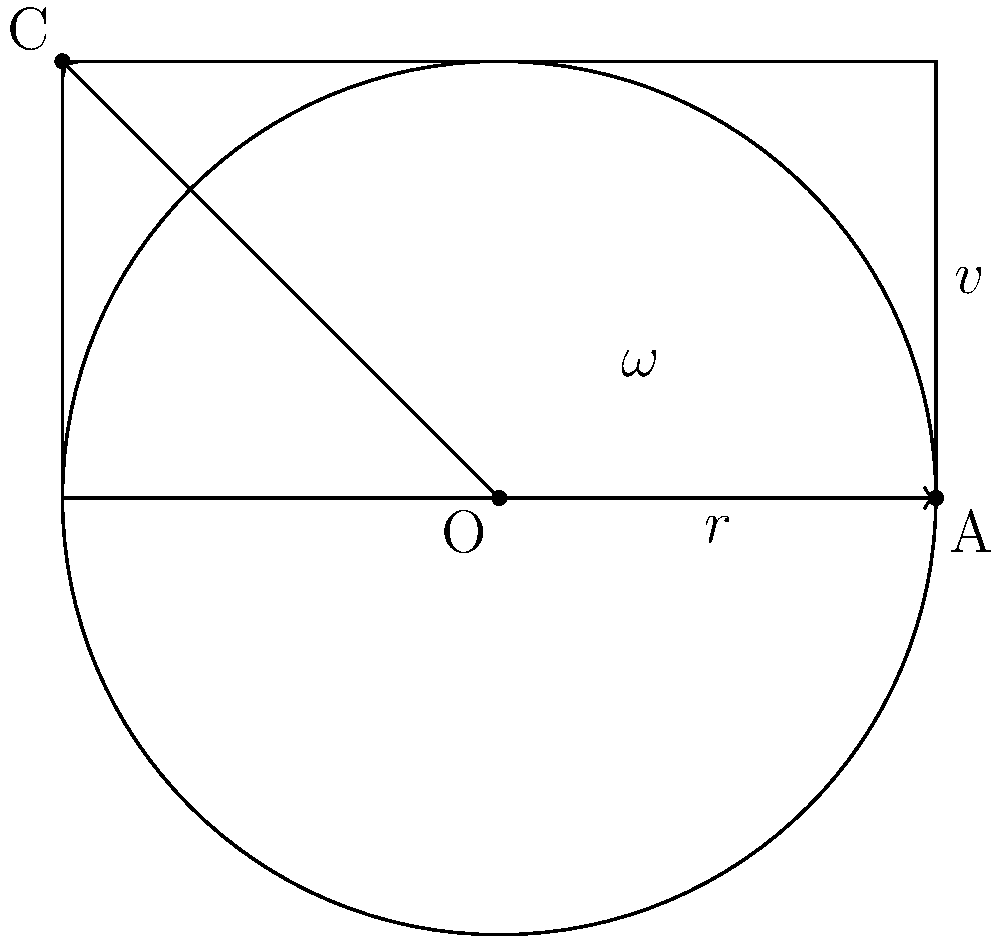In your anime-themed fighting game, a character performs a spinning kick attack. The character's foot travels in a circular path with a radius of 0.8 meters. If the foot completes one full rotation in 0.5 seconds and has a tangential velocity of 10 m/s at point A, determine:

a) The angular velocity ($\omega$) of the rotation.
b) The number of rotations the character completes in 3 seconds. Let's approach this step-by-step:

1) First, we need to calculate the angular velocity ($\omega$).

   We can use two methods to find $\omega$:

   a) Using the period of rotation:
      $\omega = \frac{2\pi}{T}$, where T is the period (time for one rotation)
      $\omega = \frac{2\pi}{0.5} = 4\pi$ rad/s

   b) Using the tangential velocity:
      $v = r\omega$, where v is tangential velocity and r is radius
      $10 = 0.8\omega$
      $\omega = \frac{10}{0.8} = 12.5$ rad/s

   The second method gives us the precise value, so we'll use 12.5 rad/s.

2) To find the number of rotations in 3 seconds:

   We know that angular velocity is the rate of change of angular position.
   In 3 seconds, the total angular displacement will be:
   $\theta = \omega t = 12.5 \times 3 = 37.5$ radians

   To convert this to rotations, we divide by $2\pi$:
   Number of rotations = $\frac{37.5}{2\pi} \approx 5.97$ rotations

Therefore, the character completes approximately 5.97 rotations in 3 seconds.
Answer: a) $\omega = 12.5$ rad/s
b) 5.97 rotations 